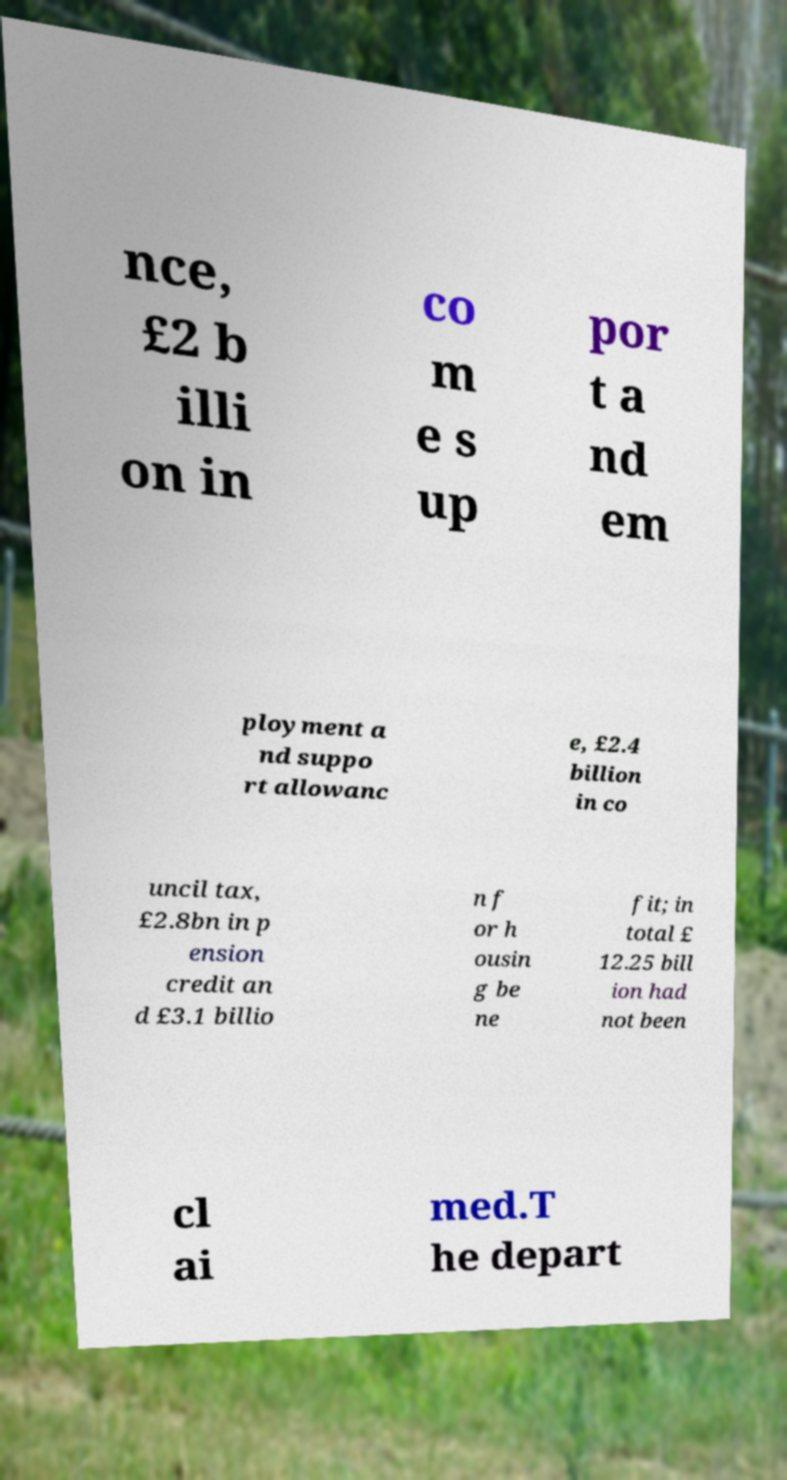For documentation purposes, I need the text within this image transcribed. Could you provide that? nce, £2 b illi on in co m e s up por t a nd em ployment a nd suppo rt allowanc e, £2.4 billion in co uncil tax, £2.8bn in p ension credit an d £3.1 billio n f or h ousin g be ne fit; in total £ 12.25 bill ion had not been cl ai med.T he depart 